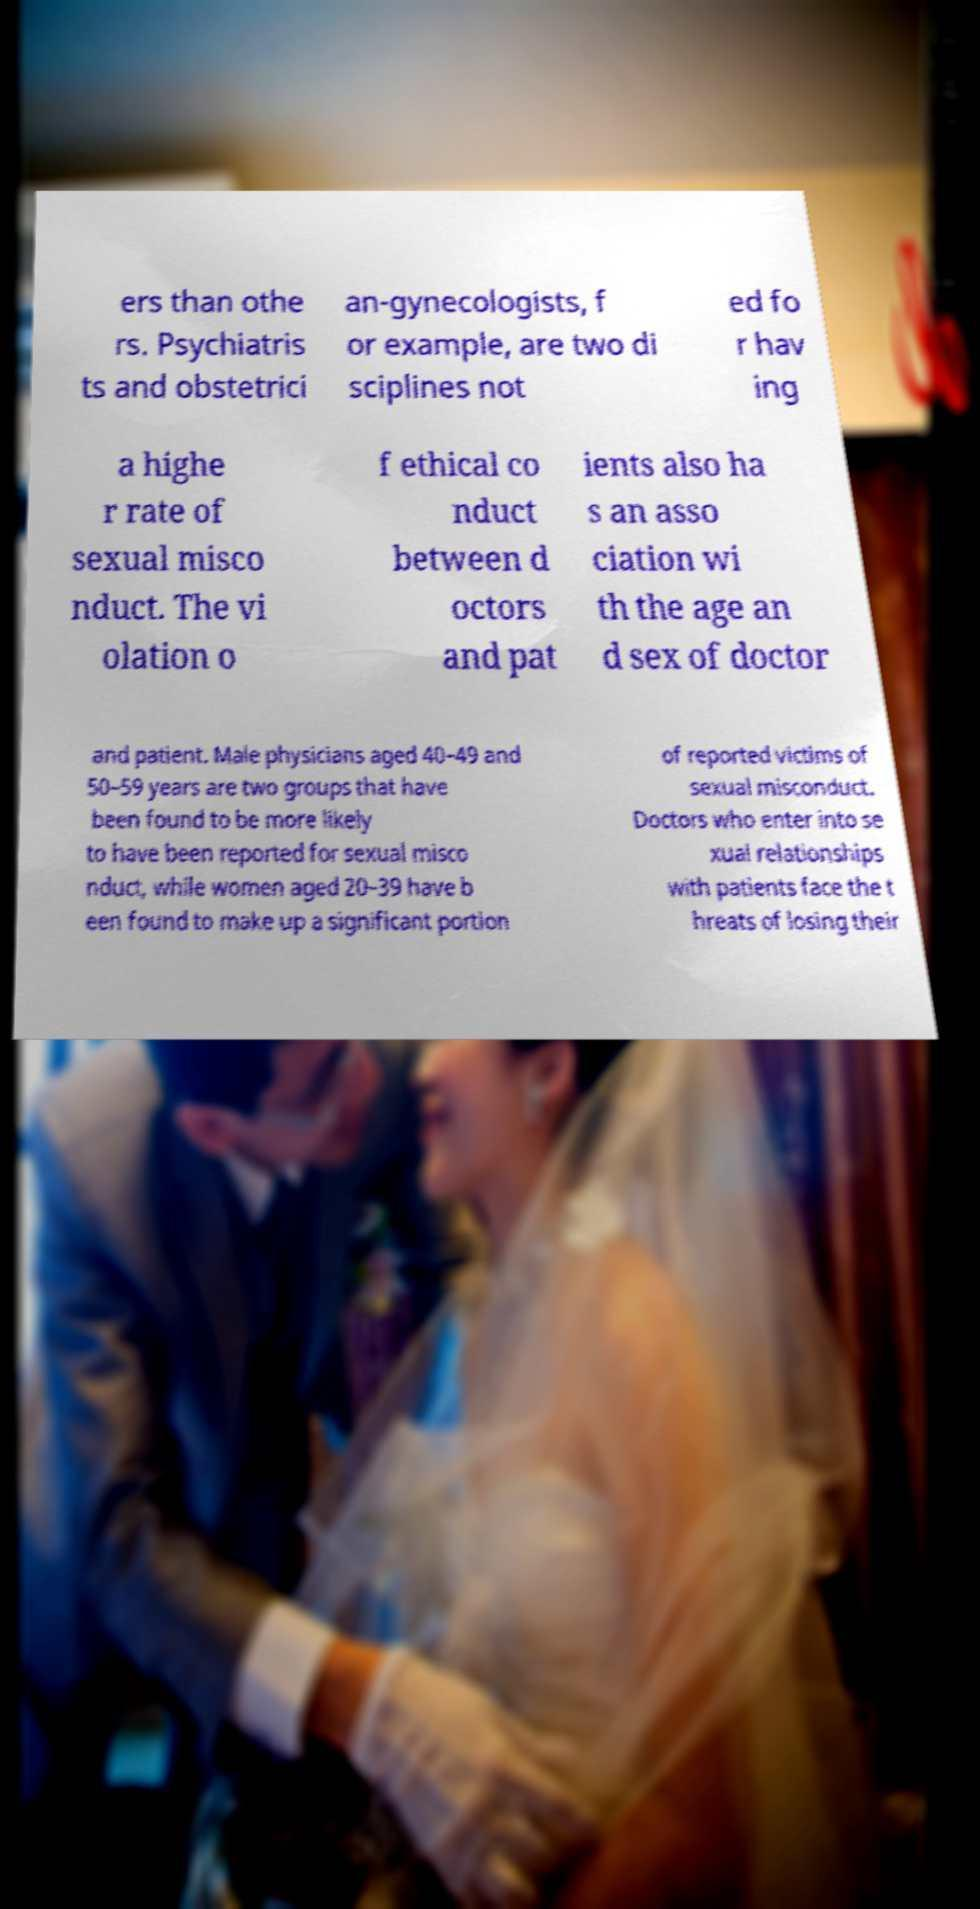For documentation purposes, I need the text within this image transcribed. Could you provide that? ers than othe rs. Psychiatris ts and obstetrici an-gynecologists, f or example, are two di sciplines not ed fo r hav ing a highe r rate of sexual misco nduct. The vi olation o f ethical co nduct between d octors and pat ients also ha s an asso ciation wi th the age an d sex of doctor and patient. Male physicians aged 40–49 and 50–59 years are two groups that have been found to be more likely to have been reported for sexual misco nduct, while women aged 20–39 have b een found to make up a significant portion of reported victims of sexual misconduct. Doctors who enter into se xual relationships with patients face the t hreats of losing their 